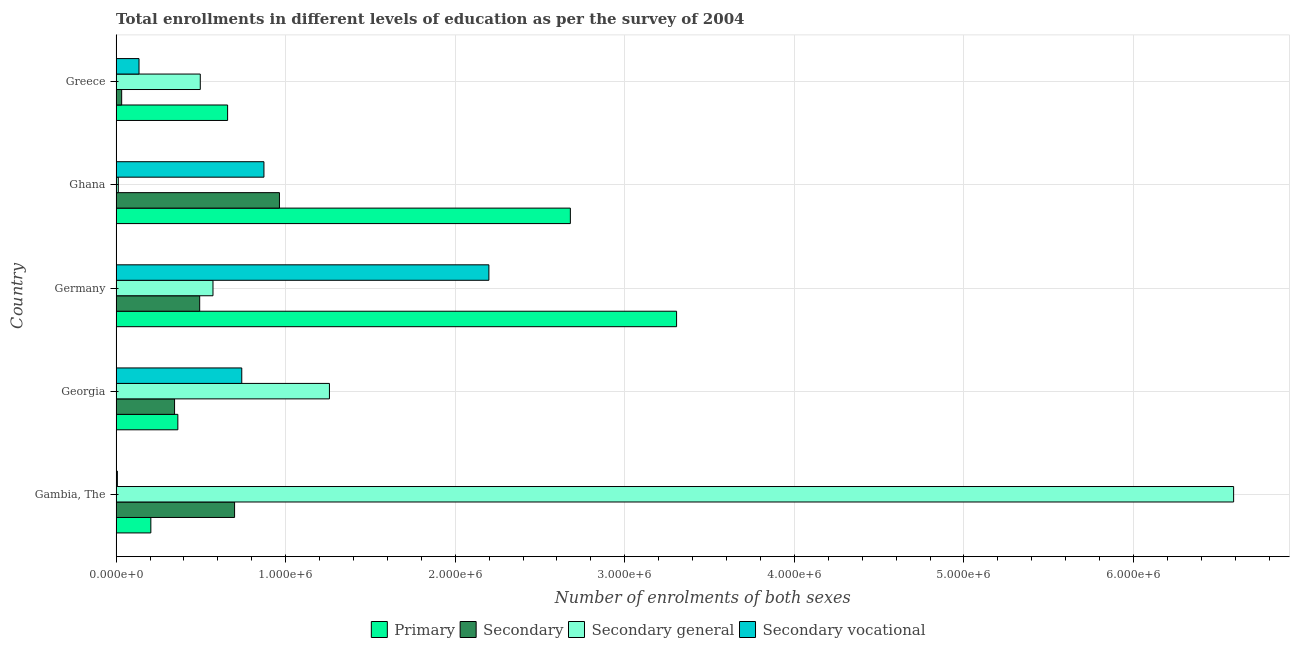How many different coloured bars are there?
Your answer should be very brief. 4. Are the number of bars per tick equal to the number of legend labels?
Provide a succinct answer. Yes. Are the number of bars on each tick of the Y-axis equal?
Keep it short and to the point. Yes. What is the label of the 4th group of bars from the top?
Offer a terse response. Georgia. In how many cases, is the number of bars for a given country not equal to the number of legend labels?
Provide a short and direct response. 0. What is the number of enrolments in secondary general education in Georgia?
Offer a terse response. 1.26e+06. Across all countries, what is the maximum number of enrolments in primary education?
Your answer should be compact. 3.31e+06. Across all countries, what is the minimum number of enrolments in secondary vocational education?
Offer a terse response. 7300. In which country was the number of enrolments in secondary general education maximum?
Provide a short and direct response. Gambia, The. In which country was the number of enrolments in primary education minimum?
Give a very brief answer. Gambia, The. What is the total number of enrolments in secondary education in the graph?
Provide a succinct answer. 2.53e+06. What is the difference between the number of enrolments in primary education in Gambia, The and that in Greece?
Your answer should be very brief. -4.53e+05. What is the difference between the number of enrolments in primary education in Gambia, The and the number of enrolments in secondary vocational education in Greece?
Provide a short and direct response. 6.98e+04. What is the average number of enrolments in secondary education per country?
Offer a very short reply. 5.06e+05. What is the difference between the number of enrolments in secondary general education and number of enrolments in secondary vocational education in Germany?
Offer a very short reply. -1.63e+06. In how many countries, is the number of enrolments in primary education greater than 2800000 ?
Your answer should be compact. 1. What is the ratio of the number of enrolments in secondary education in Germany to that in Greece?
Offer a terse response. 15.07. Is the number of enrolments in secondary general education in Georgia less than that in Ghana?
Your response must be concise. No. Is the difference between the number of enrolments in primary education in Georgia and Ghana greater than the difference between the number of enrolments in secondary vocational education in Georgia and Ghana?
Offer a very short reply. No. What is the difference between the highest and the second highest number of enrolments in primary education?
Make the answer very short. 6.26e+05. What is the difference between the highest and the lowest number of enrolments in secondary vocational education?
Your answer should be very brief. 2.19e+06. In how many countries, is the number of enrolments in secondary vocational education greater than the average number of enrolments in secondary vocational education taken over all countries?
Ensure brevity in your answer.  2. Is the sum of the number of enrolments in secondary education in Georgia and Germany greater than the maximum number of enrolments in secondary vocational education across all countries?
Your answer should be compact. No. What does the 2nd bar from the top in Ghana represents?
Ensure brevity in your answer.  Secondary general. What does the 4th bar from the bottom in Ghana represents?
Keep it short and to the point. Secondary vocational. Is it the case that in every country, the sum of the number of enrolments in primary education and number of enrolments in secondary education is greater than the number of enrolments in secondary general education?
Offer a terse response. No. How many countries are there in the graph?
Provide a short and direct response. 5. What is the difference between two consecutive major ticks on the X-axis?
Your answer should be compact. 1.00e+06. Are the values on the major ticks of X-axis written in scientific E-notation?
Keep it short and to the point. Yes. Does the graph contain any zero values?
Your answer should be compact. No. Does the graph contain grids?
Provide a succinct answer. Yes. Where does the legend appear in the graph?
Offer a very short reply. Bottom center. How many legend labels are there?
Give a very brief answer. 4. How are the legend labels stacked?
Provide a short and direct response. Horizontal. What is the title of the graph?
Ensure brevity in your answer.  Total enrollments in different levels of education as per the survey of 2004. What is the label or title of the X-axis?
Your response must be concise. Number of enrolments of both sexes. What is the Number of enrolments of both sexes of Primary in Gambia, The?
Your answer should be compact. 2.05e+05. What is the Number of enrolments of both sexes of Secondary in Gambia, The?
Provide a short and direct response. 6.99e+05. What is the Number of enrolments of both sexes in Secondary general in Gambia, The?
Offer a terse response. 6.59e+06. What is the Number of enrolments of both sexes of Secondary vocational in Gambia, The?
Ensure brevity in your answer.  7300. What is the Number of enrolments of both sexes of Primary in Georgia?
Offer a very short reply. 3.64e+05. What is the Number of enrolments of both sexes in Secondary in Georgia?
Your answer should be compact. 3.45e+05. What is the Number of enrolments of both sexes in Secondary general in Georgia?
Your answer should be very brief. 1.26e+06. What is the Number of enrolments of both sexes of Secondary vocational in Georgia?
Provide a short and direct response. 7.41e+05. What is the Number of enrolments of both sexes of Primary in Germany?
Your answer should be compact. 3.31e+06. What is the Number of enrolments of both sexes of Secondary in Germany?
Your answer should be compact. 4.93e+05. What is the Number of enrolments of both sexes of Secondary general in Germany?
Offer a terse response. 5.71e+05. What is the Number of enrolments of both sexes of Secondary vocational in Germany?
Give a very brief answer. 2.20e+06. What is the Number of enrolments of both sexes of Primary in Ghana?
Ensure brevity in your answer.  2.68e+06. What is the Number of enrolments of both sexes in Secondary in Ghana?
Make the answer very short. 9.63e+05. What is the Number of enrolments of both sexes in Secondary general in Ghana?
Give a very brief answer. 1.29e+04. What is the Number of enrolments of both sexes of Secondary vocational in Ghana?
Your answer should be compact. 8.72e+05. What is the Number of enrolments of both sexes in Primary in Greece?
Your answer should be very brief. 6.57e+05. What is the Number of enrolments of both sexes in Secondary in Greece?
Your answer should be very brief. 3.27e+04. What is the Number of enrolments of both sexes in Secondary general in Greece?
Provide a short and direct response. 4.96e+05. What is the Number of enrolments of both sexes in Secondary vocational in Greece?
Ensure brevity in your answer.  1.35e+05. Across all countries, what is the maximum Number of enrolments of both sexes in Primary?
Your response must be concise. 3.31e+06. Across all countries, what is the maximum Number of enrolments of both sexes in Secondary?
Ensure brevity in your answer.  9.63e+05. Across all countries, what is the maximum Number of enrolments of both sexes in Secondary general?
Provide a succinct answer. 6.59e+06. Across all countries, what is the maximum Number of enrolments of both sexes of Secondary vocational?
Ensure brevity in your answer.  2.20e+06. Across all countries, what is the minimum Number of enrolments of both sexes of Primary?
Give a very brief answer. 2.05e+05. Across all countries, what is the minimum Number of enrolments of both sexes of Secondary?
Keep it short and to the point. 3.27e+04. Across all countries, what is the minimum Number of enrolments of both sexes in Secondary general?
Keep it short and to the point. 1.29e+04. Across all countries, what is the minimum Number of enrolments of both sexes of Secondary vocational?
Make the answer very short. 7300. What is the total Number of enrolments of both sexes of Primary in the graph?
Give a very brief answer. 7.21e+06. What is the total Number of enrolments of both sexes of Secondary in the graph?
Offer a very short reply. 2.53e+06. What is the total Number of enrolments of both sexes of Secondary general in the graph?
Make the answer very short. 8.93e+06. What is the total Number of enrolments of both sexes of Secondary vocational in the graph?
Give a very brief answer. 3.95e+06. What is the difference between the Number of enrolments of both sexes of Primary in Gambia, The and that in Georgia?
Your answer should be very brief. -1.59e+05. What is the difference between the Number of enrolments of both sexes in Secondary in Gambia, The and that in Georgia?
Ensure brevity in your answer.  3.54e+05. What is the difference between the Number of enrolments of both sexes in Secondary general in Gambia, The and that in Georgia?
Your response must be concise. 5.33e+06. What is the difference between the Number of enrolments of both sexes in Secondary vocational in Gambia, The and that in Georgia?
Provide a short and direct response. -7.34e+05. What is the difference between the Number of enrolments of both sexes in Primary in Gambia, The and that in Germany?
Provide a short and direct response. -3.10e+06. What is the difference between the Number of enrolments of both sexes in Secondary in Gambia, The and that in Germany?
Your response must be concise. 2.06e+05. What is the difference between the Number of enrolments of both sexes in Secondary general in Gambia, The and that in Germany?
Your response must be concise. 6.02e+06. What is the difference between the Number of enrolments of both sexes of Secondary vocational in Gambia, The and that in Germany?
Provide a short and direct response. -2.19e+06. What is the difference between the Number of enrolments of both sexes of Primary in Gambia, The and that in Ghana?
Give a very brief answer. -2.47e+06. What is the difference between the Number of enrolments of both sexes of Secondary in Gambia, The and that in Ghana?
Give a very brief answer. -2.65e+05. What is the difference between the Number of enrolments of both sexes in Secondary general in Gambia, The and that in Ghana?
Make the answer very short. 6.58e+06. What is the difference between the Number of enrolments of both sexes in Secondary vocational in Gambia, The and that in Ghana?
Your answer should be compact. -8.64e+05. What is the difference between the Number of enrolments of both sexes in Primary in Gambia, The and that in Greece?
Your answer should be very brief. -4.53e+05. What is the difference between the Number of enrolments of both sexes in Secondary in Gambia, The and that in Greece?
Provide a short and direct response. 6.66e+05. What is the difference between the Number of enrolments of both sexes of Secondary general in Gambia, The and that in Greece?
Make the answer very short. 6.09e+06. What is the difference between the Number of enrolments of both sexes of Secondary vocational in Gambia, The and that in Greece?
Your response must be concise. -1.28e+05. What is the difference between the Number of enrolments of both sexes in Primary in Georgia and that in Germany?
Offer a very short reply. -2.94e+06. What is the difference between the Number of enrolments of both sexes in Secondary in Georgia and that in Germany?
Offer a terse response. -1.48e+05. What is the difference between the Number of enrolments of both sexes in Secondary general in Georgia and that in Germany?
Provide a short and direct response. 6.87e+05. What is the difference between the Number of enrolments of both sexes of Secondary vocational in Georgia and that in Germany?
Offer a terse response. -1.46e+06. What is the difference between the Number of enrolments of both sexes of Primary in Georgia and that in Ghana?
Ensure brevity in your answer.  -2.31e+06. What is the difference between the Number of enrolments of both sexes in Secondary in Georgia and that in Ghana?
Your response must be concise. -6.19e+05. What is the difference between the Number of enrolments of both sexes of Secondary general in Georgia and that in Ghana?
Ensure brevity in your answer.  1.25e+06. What is the difference between the Number of enrolments of both sexes of Secondary vocational in Georgia and that in Ghana?
Provide a succinct answer. -1.31e+05. What is the difference between the Number of enrolments of both sexes of Primary in Georgia and that in Greece?
Provide a short and direct response. -2.94e+05. What is the difference between the Number of enrolments of both sexes in Secondary in Georgia and that in Greece?
Make the answer very short. 3.12e+05. What is the difference between the Number of enrolments of both sexes in Secondary general in Georgia and that in Greece?
Offer a terse response. 7.62e+05. What is the difference between the Number of enrolments of both sexes in Secondary vocational in Georgia and that in Greece?
Your answer should be compact. 6.06e+05. What is the difference between the Number of enrolments of both sexes in Primary in Germany and that in Ghana?
Ensure brevity in your answer.  6.26e+05. What is the difference between the Number of enrolments of both sexes of Secondary in Germany and that in Ghana?
Ensure brevity in your answer.  -4.70e+05. What is the difference between the Number of enrolments of both sexes of Secondary general in Germany and that in Ghana?
Your answer should be very brief. 5.58e+05. What is the difference between the Number of enrolments of both sexes in Secondary vocational in Germany and that in Ghana?
Offer a very short reply. 1.33e+06. What is the difference between the Number of enrolments of both sexes in Primary in Germany and that in Greece?
Your answer should be very brief. 2.65e+06. What is the difference between the Number of enrolments of both sexes in Secondary in Germany and that in Greece?
Your answer should be very brief. 4.60e+05. What is the difference between the Number of enrolments of both sexes of Secondary general in Germany and that in Greece?
Make the answer very short. 7.50e+04. What is the difference between the Number of enrolments of both sexes of Secondary vocational in Germany and that in Greece?
Your answer should be compact. 2.06e+06. What is the difference between the Number of enrolments of both sexes of Primary in Ghana and that in Greece?
Make the answer very short. 2.02e+06. What is the difference between the Number of enrolments of both sexes of Secondary in Ghana and that in Greece?
Ensure brevity in your answer.  9.31e+05. What is the difference between the Number of enrolments of both sexes in Secondary general in Ghana and that in Greece?
Offer a very short reply. -4.83e+05. What is the difference between the Number of enrolments of both sexes in Secondary vocational in Ghana and that in Greece?
Keep it short and to the point. 7.37e+05. What is the difference between the Number of enrolments of both sexes in Primary in Gambia, The and the Number of enrolments of both sexes in Secondary in Georgia?
Your answer should be compact. -1.40e+05. What is the difference between the Number of enrolments of both sexes of Primary in Gambia, The and the Number of enrolments of both sexes of Secondary general in Georgia?
Give a very brief answer. -1.05e+06. What is the difference between the Number of enrolments of both sexes of Primary in Gambia, The and the Number of enrolments of both sexes of Secondary vocational in Georgia?
Your response must be concise. -5.36e+05. What is the difference between the Number of enrolments of both sexes in Secondary in Gambia, The and the Number of enrolments of both sexes in Secondary general in Georgia?
Keep it short and to the point. -5.59e+05. What is the difference between the Number of enrolments of both sexes of Secondary in Gambia, The and the Number of enrolments of both sexes of Secondary vocational in Georgia?
Your answer should be very brief. -4.24e+04. What is the difference between the Number of enrolments of both sexes of Secondary general in Gambia, The and the Number of enrolments of both sexes of Secondary vocational in Georgia?
Give a very brief answer. 5.85e+06. What is the difference between the Number of enrolments of both sexes in Primary in Gambia, The and the Number of enrolments of both sexes in Secondary in Germany?
Ensure brevity in your answer.  -2.88e+05. What is the difference between the Number of enrolments of both sexes in Primary in Gambia, The and the Number of enrolments of both sexes in Secondary general in Germany?
Your answer should be compact. -3.67e+05. What is the difference between the Number of enrolments of both sexes in Primary in Gambia, The and the Number of enrolments of both sexes in Secondary vocational in Germany?
Keep it short and to the point. -1.99e+06. What is the difference between the Number of enrolments of both sexes in Secondary in Gambia, The and the Number of enrolments of both sexes in Secondary general in Germany?
Give a very brief answer. 1.27e+05. What is the difference between the Number of enrolments of both sexes in Secondary in Gambia, The and the Number of enrolments of both sexes in Secondary vocational in Germany?
Provide a short and direct response. -1.50e+06. What is the difference between the Number of enrolments of both sexes in Secondary general in Gambia, The and the Number of enrolments of both sexes in Secondary vocational in Germany?
Provide a short and direct response. 4.39e+06. What is the difference between the Number of enrolments of both sexes in Primary in Gambia, The and the Number of enrolments of both sexes in Secondary in Ghana?
Make the answer very short. -7.59e+05. What is the difference between the Number of enrolments of both sexes in Primary in Gambia, The and the Number of enrolments of both sexes in Secondary general in Ghana?
Offer a terse response. 1.92e+05. What is the difference between the Number of enrolments of both sexes in Primary in Gambia, The and the Number of enrolments of both sexes in Secondary vocational in Ghana?
Give a very brief answer. -6.67e+05. What is the difference between the Number of enrolments of both sexes in Secondary in Gambia, The and the Number of enrolments of both sexes in Secondary general in Ghana?
Your answer should be very brief. 6.86e+05. What is the difference between the Number of enrolments of both sexes in Secondary in Gambia, The and the Number of enrolments of both sexes in Secondary vocational in Ghana?
Keep it short and to the point. -1.73e+05. What is the difference between the Number of enrolments of both sexes in Secondary general in Gambia, The and the Number of enrolments of both sexes in Secondary vocational in Ghana?
Your response must be concise. 5.72e+06. What is the difference between the Number of enrolments of both sexes of Primary in Gambia, The and the Number of enrolments of both sexes of Secondary in Greece?
Your response must be concise. 1.72e+05. What is the difference between the Number of enrolments of both sexes of Primary in Gambia, The and the Number of enrolments of both sexes of Secondary general in Greece?
Provide a short and direct response. -2.92e+05. What is the difference between the Number of enrolments of both sexes of Primary in Gambia, The and the Number of enrolments of both sexes of Secondary vocational in Greece?
Offer a very short reply. 6.98e+04. What is the difference between the Number of enrolments of both sexes in Secondary in Gambia, The and the Number of enrolments of both sexes in Secondary general in Greece?
Your response must be concise. 2.02e+05. What is the difference between the Number of enrolments of both sexes in Secondary in Gambia, The and the Number of enrolments of both sexes in Secondary vocational in Greece?
Provide a succinct answer. 5.64e+05. What is the difference between the Number of enrolments of both sexes of Secondary general in Gambia, The and the Number of enrolments of both sexes of Secondary vocational in Greece?
Make the answer very short. 6.46e+06. What is the difference between the Number of enrolments of both sexes in Primary in Georgia and the Number of enrolments of both sexes in Secondary in Germany?
Your answer should be very brief. -1.29e+05. What is the difference between the Number of enrolments of both sexes of Primary in Georgia and the Number of enrolments of both sexes of Secondary general in Germany?
Keep it short and to the point. -2.07e+05. What is the difference between the Number of enrolments of both sexes of Primary in Georgia and the Number of enrolments of both sexes of Secondary vocational in Germany?
Provide a succinct answer. -1.83e+06. What is the difference between the Number of enrolments of both sexes of Secondary in Georgia and the Number of enrolments of both sexes of Secondary general in Germany?
Give a very brief answer. -2.27e+05. What is the difference between the Number of enrolments of both sexes of Secondary in Georgia and the Number of enrolments of both sexes of Secondary vocational in Germany?
Offer a very short reply. -1.85e+06. What is the difference between the Number of enrolments of both sexes of Secondary general in Georgia and the Number of enrolments of both sexes of Secondary vocational in Germany?
Your answer should be very brief. -9.40e+05. What is the difference between the Number of enrolments of both sexes of Primary in Georgia and the Number of enrolments of both sexes of Secondary in Ghana?
Make the answer very short. -5.99e+05. What is the difference between the Number of enrolments of both sexes of Primary in Georgia and the Number of enrolments of both sexes of Secondary general in Ghana?
Offer a very short reply. 3.51e+05. What is the difference between the Number of enrolments of both sexes in Primary in Georgia and the Number of enrolments of both sexes in Secondary vocational in Ghana?
Make the answer very short. -5.08e+05. What is the difference between the Number of enrolments of both sexes of Secondary in Georgia and the Number of enrolments of both sexes of Secondary general in Ghana?
Ensure brevity in your answer.  3.32e+05. What is the difference between the Number of enrolments of both sexes of Secondary in Georgia and the Number of enrolments of both sexes of Secondary vocational in Ghana?
Keep it short and to the point. -5.27e+05. What is the difference between the Number of enrolments of both sexes in Secondary general in Georgia and the Number of enrolments of both sexes in Secondary vocational in Ghana?
Offer a very short reply. 3.86e+05. What is the difference between the Number of enrolments of both sexes in Primary in Georgia and the Number of enrolments of both sexes in Secondary in Greece?
Ensure brevity in your answer.  3.31e+05. What is the difference between the Number of enrolments of both sexes of Primary in Georgia and the Number of enrolments of both sexes of Secondary general in Greece?
Make the answer very short. -1.32e+05. What is the difference between the Number of enrolments of both sexes of Primary in Georgia and the Number of enrolments of both sexes of Secondary vocational in Greece?
Offer a terse response. 2.29e+05. What is the difference between the Number of enrolments of both sexes in Secondary in Georgia and the Number of enrolments of both sexes in Secondary general in Greece?
Ensure brevity in your answer.  -1.52e+05. What is the difference between the Number of enrolments of both sexes in Secondary in Georgia and the Number of enrolments of both sexes in Secondary vocational in Greece?
Your answer should be compact. 2.10e+05. What is the difference between the Number of enrolments of both sexes in Secondary general in Georgia and the Number of enrolments of both sexes in Secondary vocational in Greece?
Offer a terse response. 1.12e+06. What is the difference between the Number of enrolments of both sexes in Primary in Germany and the Number of enrolments of both sexes in Secondary in Ghana?
Make the answer very short. 2.34e+06. What is the difference between the Number of enrolments of both sexes in Primary in Germany and the Number of enrolments of both sexes in Secondary general in Ghana?
Make the answer very short. 3.29e+06. What is the difference between the Number of enrolments of both sexes of Primary in Germany and the Number of enrolments of both sexes of Secondary vocational in Ghana?
Provide a short and direct response. 2.43e+06. What is the difference between the Number of enrolments of both sexes of Secondary in Germany and the Number of enrolments of both sexes of Secondary general in Ghana?
Your response must be concise. 4.80e+05. What is the difference between the Number of enrolments of both sexes of Secondary in Germany and the Number of enrolments of both sexes of Secondary vocational in Ghana?
Give a very brief answer. -3.79e+05. What is the difference between the Number of enrolments of both sexes in Secondary general in Germany and the Number of enrolments of both sexes in Secondary vocational in Ghana?
Ensure brevity in your answer.  -3.00e+05. What is the difference between the Number of enrolments of both sexes of Primary in Germany and the Number of enrolments of both sexes of Secondary in Greece?
Your answer should be compact. 3.27e+06. What is the difference between the Number of enrolments of both sexes in Primary in Germany and the Number of enrolments of both sexes in Secondary general in Greece?
Your answer should be compact. 2.81e+06. What is the difference between the Number of enrolments of both sexes in Primary in Germany and the Number of enrolments of both sexes in Secondary vocational in Greece?
Make the answer very short. 3.17e+06. What is the difference between the Number of enrolments of both sexes in Secondary in Germany and the Number of enrolments of both sexes in Secondary general in Greece?
Ensure brevity in your answer.  -3483. What is the difference between the Number of enrolments of both sexes of Secondary in Germany and the Number of enrolments of both sexes of Secondary vocational in Greece?
Give a very brief answer. 3.58e+05. What is the difference between the Number of enrolments of both sexes in Secondary general in Germany and the Number of enrolments of both sexes in Secondary vocational in Greece?
Offer a very short reply. 4.36e+05. What is the difference between the Number of enrolments of both sexes in Primary in Ghana and the Number of enrolments of both sexes in Secondary in Greece?
Make the answer very short. 2.65e+06. What is the difference between the Number of enrolments of both sexes in Primary in Ghana and the Number of enrolments of both sexes in Secondary general in Greece?
Your response must be concise. 2.18e+06. What is the difference between the Number of enrolments of both sexes in Primary in Ghana and the Number of enrolments of both sexes in Secondary vocational in Greece?
Make the answer very short. 2.54e+06. What is the difference between the Number of enrolments of both sexes of Secondary in Ghana and the Number of enrolments of both sexes of Secondary general in Greece?
Offer a very short reply. 4.67e+05. What is the difference between the Number of enrolments of both sexes in Secondary in Ghana and the Number of enrolments of both sexes in Secondary vocational in Greece?
Your answer should be very brief. 8.28e+05. What is the difference between the Number of enrolments of both sexes of Secondary general in Ghana and the Number of enrolments of both sexes of Secondary vocational in Greece?
Offer a terse response. -1.22e+05. What is the average Number of enrolments of both sexes in Primary per country?
Make the answer very short. 1.44e+06. What is the average Number of enrolments of both sexes in Secondary per country?
Your response must be concise. 5.06e+05. What is the average Number of enrolments of both sexes in Secondary general per country?
Ensure brevity in your answer.  1.79e+06. What is the average Number of enrolments of both sexes in Secondary vocational per country?
Your answer should be compact. 7.91e+05. What is the difference between the Number of enrolments of both sexes in Primary and Number of enrolments of both sexes in Secondary in Gambia, The?
Offer a terse response. -4.94e+05. What is the difference between the Number of enrolments of both sexes of Primary and Number of enrolments of both sexes of Secondary general in Gambia, The?
Offer a very short reply. -6.39e+06. What is the difference between the Number of enrolments of both sexes of Primary and Number of enrolments of both sexes of Secondary vocational in Gambia, The?
Your response must be concise. 1.97e+05. What is the difference between the Number of enrolments of both sexes of Secondary and Number of enrolments of both sexes of Secondary general in Gambia, The?
Your response must be concise. -5.89e+06. What is the difference between the Number of enrolments of both sexes in Secondary and Number of enrolments of both sexes in Secondary vocational in Gambia, The?
Offer a terse response. 6.91e+05. What is the difference between the Number of enrolments of both sexes in Secondary general and Number of enrolments of both sexes in Secondary vocational in Gambia, The?
Your answer should be compact. 6.58e+06. What is the difference between the Number of enrolments of both sexes in Primary and Number of enrolments of both sexes in Secondary in Georgia?
Provide a succinct answer. 1.93e+04. What is the difference between the Number of enrolments of both sexes in Primary and Number of enrolments of both sexes in Secondary general in Georgia?
Give a very brief answer. -8.94e+05. What is the difference between the Number of enrolments of both sexes in Primary and Number of enrolments of both sexes in Secondary vocational in Georgia?
Offer a very short reply. -3.77e+05. What is the difference between the Number of enrolments of both sexes of Secondary and Number of enrolments of both sexes of Secondary general in Georgia?
Your answer should be compact. -9.13e+05. What is the difference between the Number of enrolments of both sexes in Secondary and Number of enrolments of both sexes in Secondary vocational in Georgia?
Keep it short and to the point. -3.96e+05. What is the difference between the Number of enrolments of both sexes in Secondary general and Number of enrolments of both sexes in Secondary vocational in Georgia?
Provide a short and direct response. 5.17e+05. What is the difference between the Number of enrolments of both sexes in Primary and Number of enrolments of both sexes in Secondary in Germany?
Your answer should be very brief. 2.81e+06. What is the difference between the Number of enrolments of both sexes of Primary and Number of enrolments of both sexes of Secondary general in Germany?
Give a very brief answer. 2.73e+06. What is the difference between the Number of enrolments of both sexes of Primary and Number of enrolments of both sexes of Secondary vocational in Germany?
Provide a succinct answer. 1.11e+06. What is the difference between the Number of enrolments of both sexes of Secondary and Number of enrolments of both sexes of Secondary general in Germany?
Provide a short and direct response. -7.85e+04. What is the difference between the Number of enrolments of both sexes of Secondary and Number of enrolments of both sexes of Secondary vocational in Germany?
Offer a terse response. -1.71e+06. What is the difference between the Number of enrolments of both sexes of Secondary general and Number of enrolments of both sexes of Secondary vocational in Germany?
Offer a very short reply. -1.63e+06. What is the difference between the Number of enrolments of both sexes of Primary and Number of enrolments of both sexes of Secondary in Ghana?
Give a very brief answer. 1.72e+06. What is the difference between the Number of enrolments of both sexes in Primary and Number of enrolments of both sexes in Secondary general in Ghana?
Provide a short and direct response. 2.67e+06. What is the difference between the Number of enrolments of both sexes of Primary and Number of enrolments of both sexes of Secondary vocational in Ghana?
Your answer should be very brief. 1.81e+06. What is the difference between the Number of enrolments of both sexes in Secondary and Number of enrolments of both sexes in Secondary general in Ghana?
Keep it short and to the point. 9.50e+05. What is the difference between the Number of enrolments of both sexes in Secondary and Number of enrolments of both sexes in Secondary vocational in Ghana?
Your answer should be compact. 9.15e+04. What is the difference between the Number of enrolments of both sexes in Secondary general and Number of enrolments of both sexes in Secondary vocational in Ghana?
Your answer should be very brief. -8.59e+05. What is the difference between the Number of enrolments of both sexes of Primary and Number of enrolments of both sexes of Secondary in Greece?
Your answer should be compact. 6.25e+05. What is the difference between the Number of enrolments of both sexes of Primary and Number of enrolments of both sexes of Secondary general in Greece?
Ensure brevity in your answer.  1.61e+05. What is the difference between the Number of enrolments of both sexes in Primary and Number of enrolments of both sexes in Secondary vocational in Greece?
Your answer should be very brief. 5.23e+05. What is the difference between the Number of enrolments of both sexes of Secondary and Number of enrolments of both sexes of Secondary general in Greece?
Offer a terse response. -4.64e+05. What is the difference between the Number of enrolments of both sexes in Secondary and Number of enrolments of both sexes in Secondary vocational in Greece?
Your response must be concise. -1.02e+05. What is the difference between the Number of enrolments of both sexes of Secondary general and Number of enrolments of both sexes of Secondary vocational in Greece?
Provide a succinct answer. 3.61e+05. What is the ratio of the Number of enrolments of both sexes in Primary in Gambia, The to that in Georgia?
Provide a short and direct response. 0.56. What is the ratio of the Number of enrolments of both sexes in Secondary in Gambia, The to that in Georgia?
Provide a succinct answer. 2.03. What is the ratio of the Number of enrolments of both sexes in Secondary general in Gambia, The to that in Georgia?
Give a very brief answer. 5.24. What is the ratio of the Number of enrolments of both sexes of Secondary vocational in Gambia, The to that in Georgia?
Provide a succinct answer. 0.01. What is the ratio of the Number of enrolments of both sexes in Primary in Gambia, The to that in Germany?
Keep it short and to the point. 0.06. What is the ratio of the Number of enrolments of both sexes of Secondary in Gambia, The to that in Germany?
Provide a succinct answer. 1.42. What is the ratio of the Number of enrolments of both sexes of Secondary general in Gambia, The to that in Germany?
Your response must be concise. 11.54. What is the ratio of the Number of enrolments of both sexes in Secondary vocational in Gambia, The to that in Germany?
Keep it short and to the point. 0. What is the ratio of the Number of enrolments of both sexes of Primary in Gambia, The to that in Ghana?
Provide a short and direct response. 0.08. What is the ratio of the Number of enrolments of both sexes in Secondary in Gambia, The to that in Ghana?
Your answer should be very brief. 0.73. What is the ratio of the Number of enrolments of both sexes in Secondary general in Gambia, The to that in Ghana?
Offer a terse response. 510.74. What is the ratio of the Number of enrolments of both sexes in Secondary vocational in Gambia, The to that in Ghana?
Provide a succinct answer. 0.01. What is the ratio of the Number of enrolments of both sexes in Primary in Gambia, The to that in Greece?
Keep it short and to the point. 0.31. What is the ratio of the Number of enrolments of both sexes in Secondary in Gambia, The to that in Greece?
Keep it short and to the point. 21.36. What is the ratio of the Number of enrolments of both sexes in Secondary general in Gambia, The to that in Greece?
Make the answer very short. 13.28. What is the ratio of the Number of enrolments of both sexes of Secondary vocational in Gambia, The to that in Greece?
Provide a succinct answer. 0.05. What is the ratio of the Number of enrolments of both sexes in Primary in Georgia to that in Germany?
Your response must be concise. 0.11. What is the ratio of the Number of enrolments of both sexes in Secondary in Georgia to that in Germany?
Your answer should be very brief. 0.7. What is the ratio of the Number of enrolments of both sexes in Secondary general in Georgia to that in Germany?
Provide a succinct answer. 2.2. What is the ratio of the Number of enrolments of both sexes of Secondary vocational in Georgia to that in Germany?
Your response must be concise. 0.34. What is the ratio of the Number of enrolments of both sexes of Primary in Georgia to that in Ghana?
Give a very brief answer. 0.14. What is the ratio of the Number of enrolments of both sexes in Secondary in Georgia to that in Ghana?
Keep it short and to the point. 0.36. What is the ratio of the Number of enrolments of both sexes of Secondary general in Georgia to that in Ghana?
Offer a terse response. 97.49. What is the ratio of the Number of enrolments of both sexes of Primary in Georgia to that in Greece?
Provide a short and direct response. 0.55. What is the ratio of the Number of enrolments of both sexes of Secondary in Georgia to that in Greece?
Ensure brevity in your answer.  10.54. What is the ratio of the Number of enrolments of both sexes in Secondary general in Georgia to that in Greece?
Provide a succinct answer. 2.53. What is the ratio of the Number of enrolments of both sexes of Secondary vocational in Georgia to that in Greece?
Provide a succinct answer. 5.49. What is the ratio of the Number of enrolments of both sexes in Primary in Germany to that in Ghana?
Your answer should be compact. 1.23. What is the ratio of the Number of enrolments of both sexes in Secondary in Germany to that in Ghana?
Keep it short and to the point. 0.51. What is the ratio of the Number of enrolments of both sexes of Secondary general in Germany to that in Ghana?
Make the answer very short. 44.27. What is the ratio of the Number of enrolments of both sexes of Secondary vocational in Germany to that in Ghana?
Make the answer very short. 2.52. What is the ratio of the Number of enrolments of both sexes in Primary in Germany to that in Greece?
Keep it short and to the point. 5.03. What is the ratio of the Number of enrolments of both sexes in Secondary in Germany to that in Greece?
Your answer should be compact. 15.07. What is the ratio of the Number of enrolments of both sexes of Secondary general in Germany to that in Greece?
Provide a succinct answer. 1.15. What is the ratio of the Number of enrolments of both sexes in Secondary vocational in Germany to that in Greece?
Your answer should be very brief. 16.29. What is the ratio of the Number of enrolments of both sexes of Primary in Ghana to that in Greece?
Give a very brief answer. 4.07. What is the ratio of the Number of enrolments of both sexes in Secondary in Ghana to that in Greece?
Provide a short and direct response. 29.46. What is the ratio of the Number of enrolments of both sexes in Secondary general in Ghana to that in Greece?
Make the answer very short. 0.03. What is the ratio of the Number of enrolments of both sexes in Secondary vocational in Ghana to that in Greece?
Make the answer very short. 6.46. What is the difference between the highest and the second highest Number of enrolments of both sexes of Primary?
Give a very brief answer. 6.26e+05. What is the difference between the highest and the second highest Number of enrolments of both sexes in Secondary?
Keep it short and to the point. 2.65e+05. What is the difference between the highest and the second highest Number of enrolments of both sexes in Secondary general?
Ensure brevity in your answer.  5.33e+06. What is the difference between the highest and the second highest Number of enrolments of both sexes of Secondary vocational?
Provide a succinct answer. 1.33e+06. What is the difference between the highest and the lowest Number of enrolments of both sexes of Primary?
Keep it short and to the point. 3.10e+06. What is the difference between the highest and the lowest Number of enrolments of both sexes in Secondary?
Provide a short and direct response. 9.31e+05. What is the difference between the highest and the lowest Number of enrolments of both sexes in Secondary general?
Ensure brevity in your answer.  6.58e+06. What is the difference between the highest and the lowest Number of enrolments of both sexes in Secondary vocational?
Offer a terse response. 2.19e+06. 